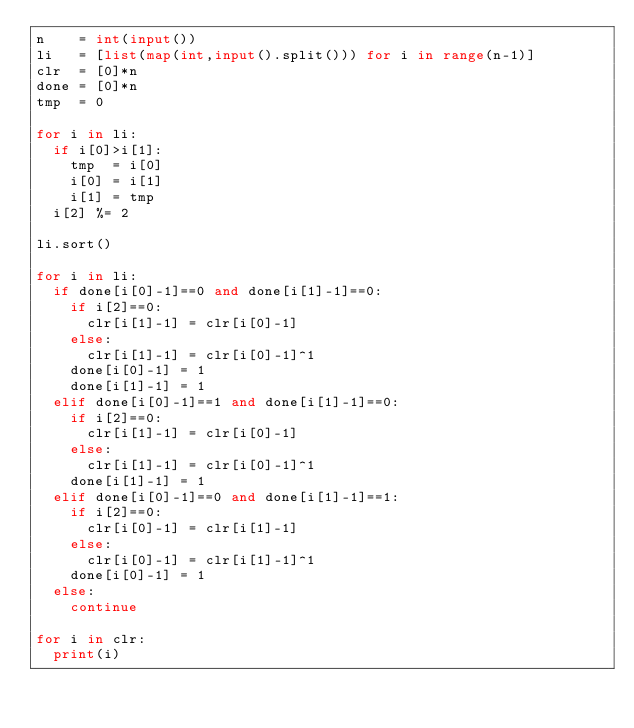<code> <loc_0><loc_0><loc_500><loc_500><_Python_>n    = int(input())
li   = [list(map(int,input().split())) for i in range(n-1)]
clr  = [0]*n
done = [0]*n
tmp  = 0

for i in li:
  if i[0]>i[1]:
    tmp  = i[0]
    i[0] = i[1]
    i[1] = tmp
  i[2] %= 2

li.sort()

for i in li:
  if done[i[0]-1]==0 and done[i[1]-1]==0:
    if i[2]==0:
      clr[i[1]-1] = clr[i[0]-1]
    else:
      clr[i[1]-1] = clr[i[0]-1]^1
    done[i[0]-1] = 1
    done[i[1]-1] = 1
  elif done[i[0]-1]==1 and done[i[1]-1]==0:
    if i[2]==0:
      clr[i[1]-1] = clr[i[0]-1]
    else:
      clr[i[1]-1] = clr[i[0]-1]^1
    done[i[1]-1] = 1
  elif done[i[0]-1]==0 and done[i[1]-1]==1:
    if i[2]==0:
      clr[i[0]-1] = clr[i[1]-1]
    else:
      clr[i[0]-1] = clr[i[1]-1]^1
    done[i[0]-1] = 1
  else:
    continue

for i in clr:
  print(i)</code> 